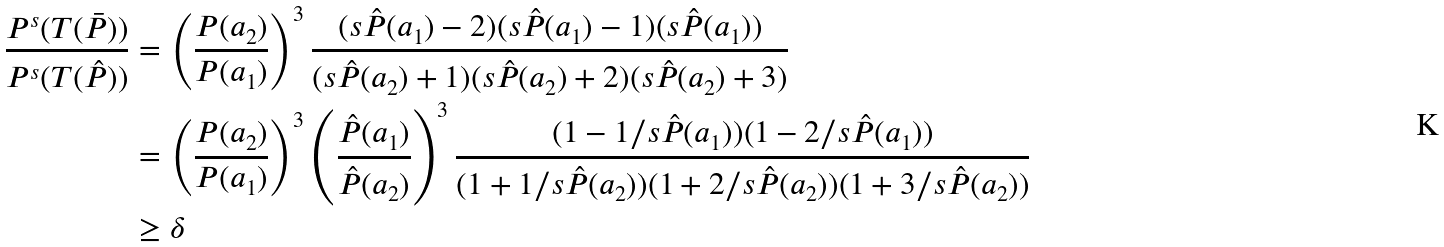<formula> <loc_0><loc_0><loc_500><loc_500>\frac { P ^ { s } ( T ( \bar { P } ) ) } { P ^ { s } ( T ( { { \hat { P } } } ) ) } & = \left ( \frac { P ( a _ { 2 } ) } { P ( a _ { 1 } ) } \right ) ^ { 3 } \frac { ( s { \hat { P } } ( a _ { 1 } ) - 2 ) ( s { \hat { P } } ( a _ { 1 } ) - 1 ) ( s { \hat { P } } ( a _ { 1 } ) ) } { ( s { \hat { P } } ( a _ { 2 } ) + 1 ) ( s { \hat { P } } ( a _ { 2 } ) + 2 ) ( s { \hat { P } } ( a _ { 2 } ) + 3 ) } \\ & = \left ( \frac { P ( a _ { 2 } ) } { P ( a _ { 1 } ) } \right ) ^ { 3 } \left ( \frac { { \hat { P } } ( a _ { 1 } ) } { { \hat { P } } ( a _ { 2 } ) } \right ) ^ { 3 } \frac { ( 1 - 1 / s { \hat { P } } ( a _ { 1 } ) ) ( 1 - 2 / s { \hat { P } } ( a _ { 1 } ) ) } { ( 1 + 1 / s { \hat { P } } ( a _ { 2 } ) ) ( 1 + 2 / s { \hat { P } } ( a _ { 2 } ) ) ( 1 + 3 / s { \hat { P } } ( a _ { 2 } ) ) } \\ & \geq \delta</formula> 